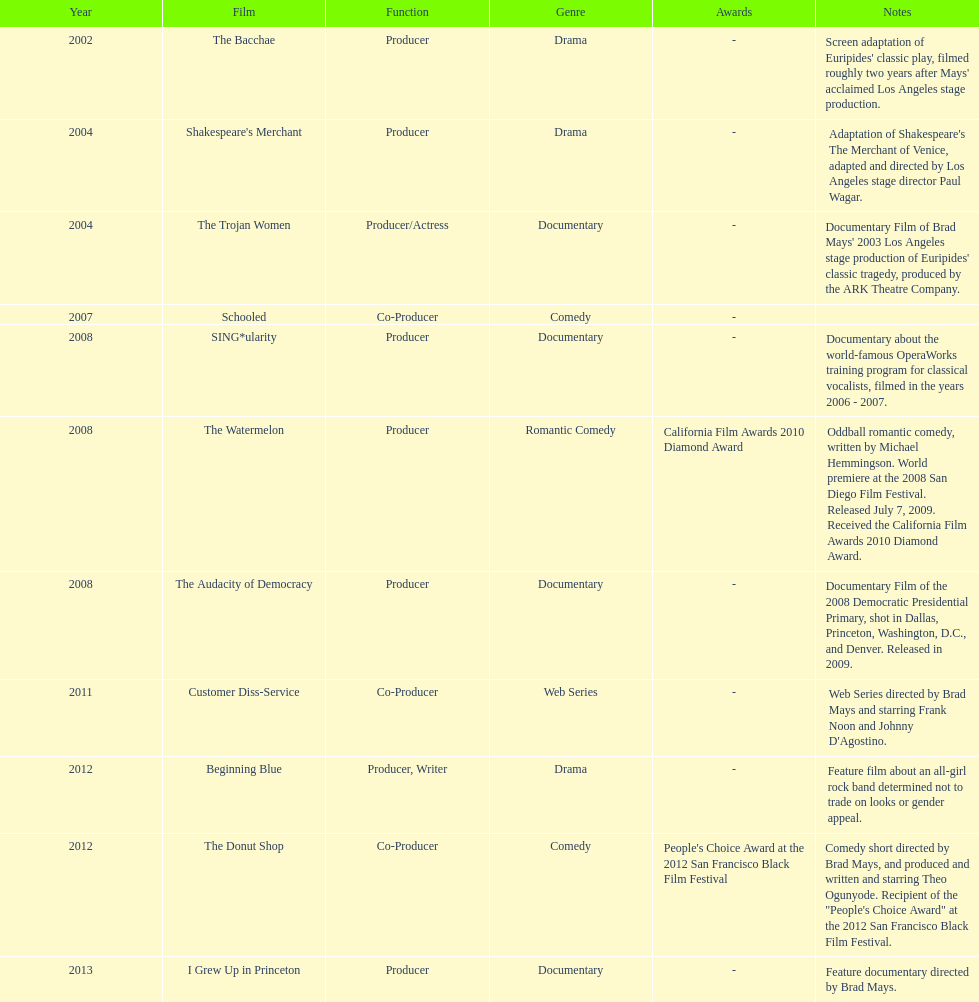How many years before was the film bacchae out before the watermelon? 6. 